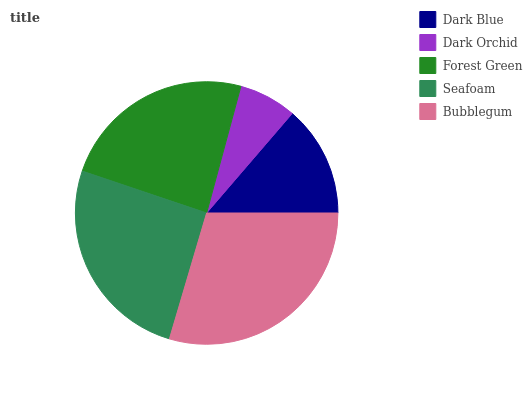Is Dark Orchid the minimum?
Answer yes or no. Yes. Is Bubblegum the maximum?
Answer yes or no. Yes. Is Forest Green the minimum?
Answer yes or no. No. Is Forest Green the maximum?
Answer yes or no. No. Is Forest Green greater than Dark Orchid?
Answer yes or no. Yes. Is Dark Orchid less than Forest Green?
Answer yes or no. Yes. Is Dark Orchid greater than Forest Green?
Answer yes or no. No. Is Forest Green less than Dark Orchid?
Answer yes or no. No. Is Forest Green the high median?
Answer yes or no. Yes. Is Forest Green the low median?
Answer yes or no. Yes. Is Dark Orchid the high median?
Answer yes or no. No. Is Seafoam the low median?
Answer yes or no. No. 